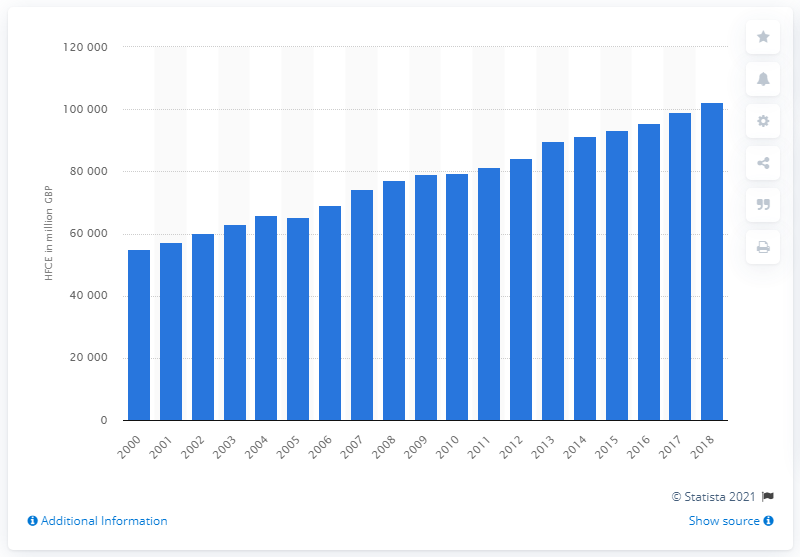Outline some significant characteristics in this image. In 2018, the total HFCE for Scotland was 102,402. 